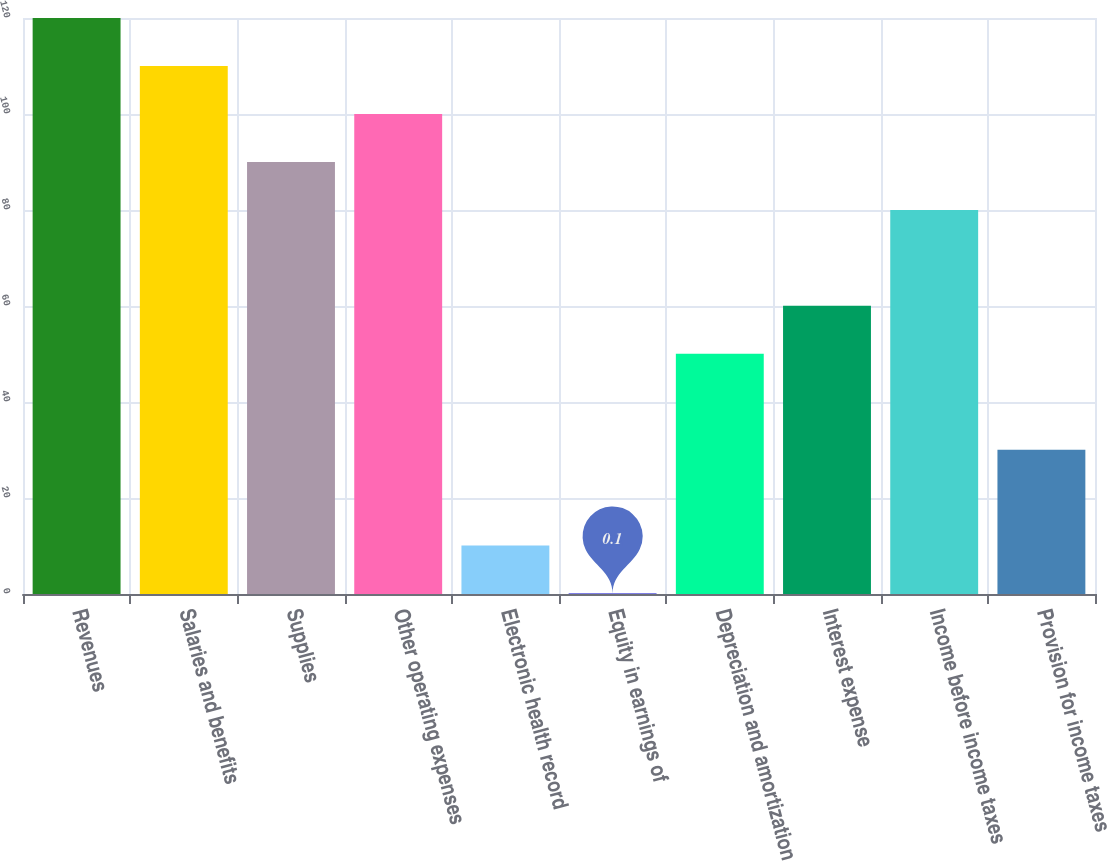Convert chart to OTSL. <chart><loc_0><loc_0><loc_500><loc_500><bar_chart><fcel>Revenues<fcel>Salaries and benefits<fcel>Supplies<fcel>Other operating expenses<fcel>Electronic health record<fcel>Equity in earnings of<fcel>Depreciation and amortization<fcel>Interest expense<fcel>Income before income taxes<fcel>Provision for income taxes<nl><fcel>119.98<fcel>109.99<fcel>90.01<fcel>100<fcel>10.09<fcel>0.1<fcel>50.05<fcel>60.04<fcel>80.02<fcel>30.07<nl></chart> 